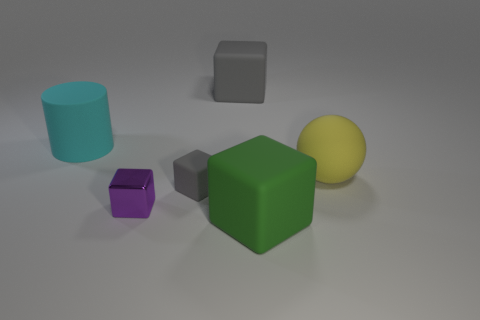What color is the cube that is both right of the purple thing and in front of the tiny gray matte cube? green 